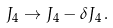<formula> <loc_0><loc_0><loc_500><loc_500>J _ { 4 } \rightarrow J _ { 4 } - \delta J _ { 4 } \, .</formula> 